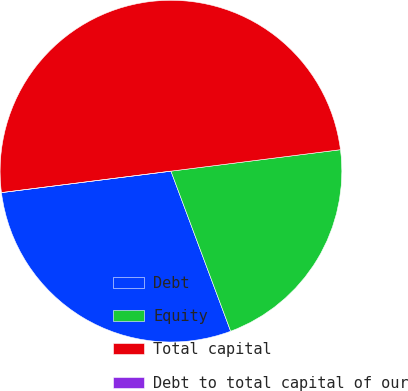<chart> <loc_0><loc_0><loc_500><loc_500><pie_chart><fcel>Debt<fcel>Equity<fcel>Total capital<fcel>Debt to total capital of our<nl><fcel>28.68%<fcel>21.32%<fcel>50.0%<fcel>0.0%<nl></chart> 